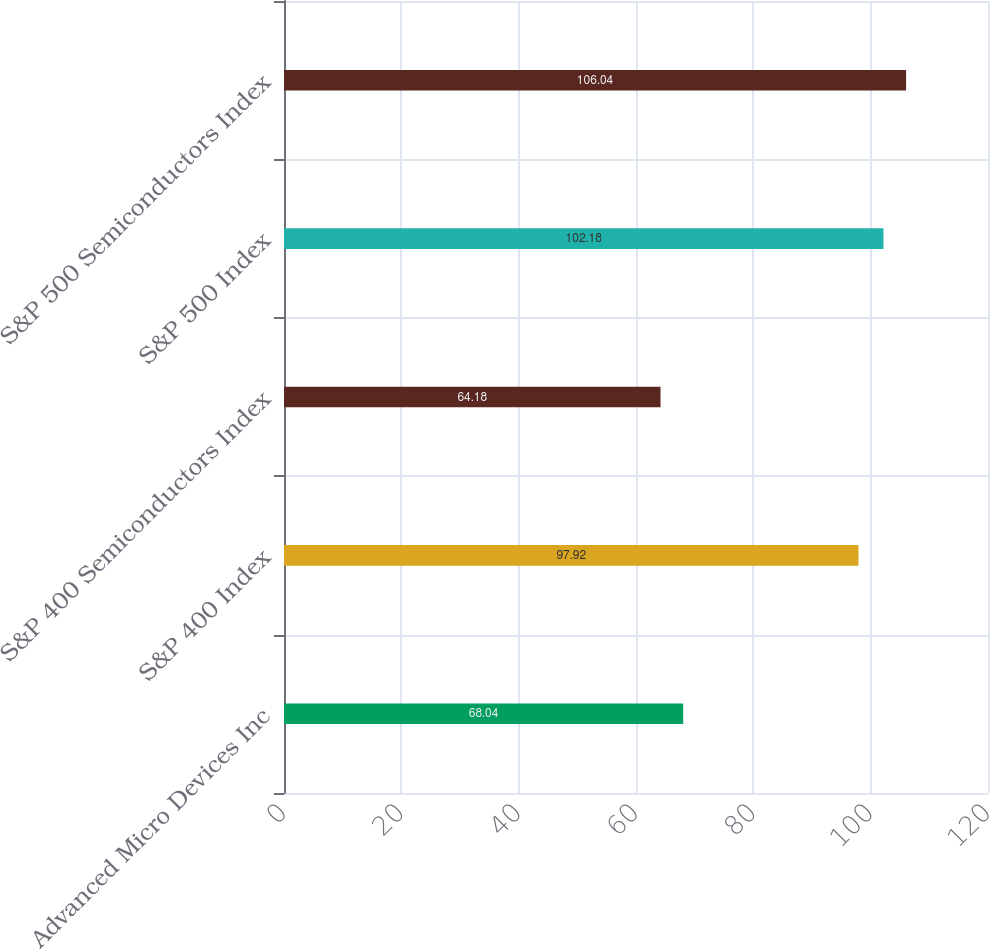Convert chart. <chart><loc_0><loc_0><loc_500><loc_500><bar_chart><fcel>Advanced Micro Devices Inc<fcel>S&P 400 Index<fcel>S&P 400 Semiconductors Index<fcel>S&P 500 Index<fcel>S&P 500 Semiconductors Index<nl><fcel>68.04<fcel>97.92<fcel>64.18<fcel>102.18<fcel>106.04<nl></chart> 